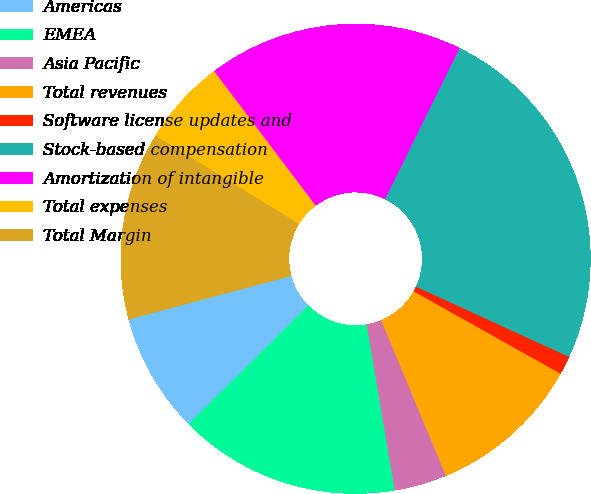Convert chart. <chart><loc_0><loc_0><loc_500><loc_500><pie_chart><fcel>Americas<fcel>EMEA<fcel>Asia Pacific<fcel>Total revenues<fcel>Software license updates and<fcel>Stock-based compensation<fcel>Amortization of intangible<fcel>Total expenses<fcel>Total Margin<nl><fcel>8.27%<fcel>15.25%<fcel>3.61%<fcel>10.59%<fcel>1.28%<fcel>24.56%<fcel>17.58%<fcel>5.94%<fcel>12.92%<nl></chart> 